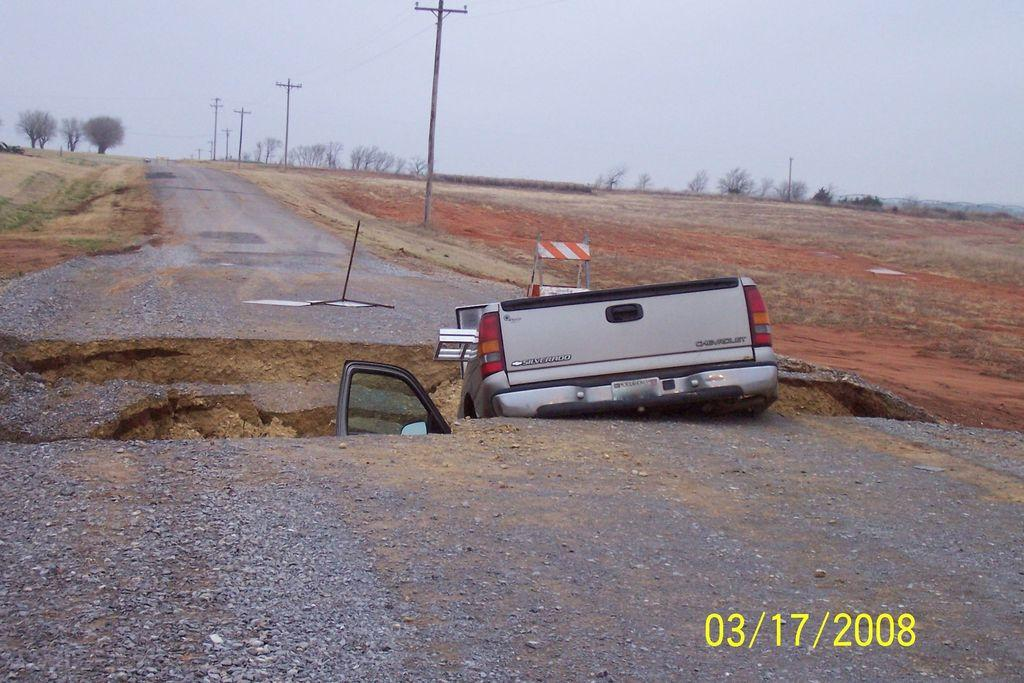What structures can be seen in the image? There are electrical poles in the image. What type of natural elements are present in the image? There are trees in the image. What is visible in the background of the image? The sky is visible in the image. What mode of transportation can be seen in the image? There is a vehicle on the road in the image. What type of apparatus is being used by the deer in the image? There are no deer present in the image, and therefore no apparatus can be associated with them. 